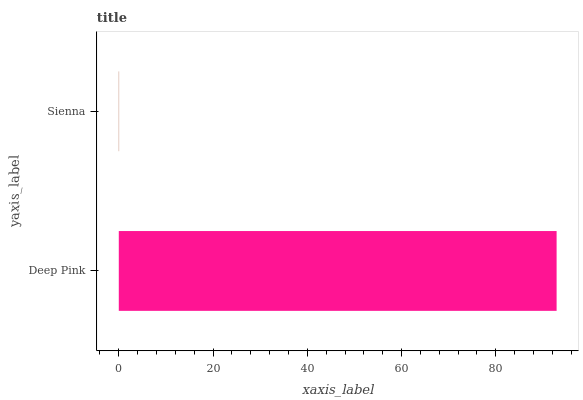Is Sienna the minimum?
Answer yes or no. Yes. Is Deep Pink the maximum?
Answer yes or no. Yes. Is Sienna the maximum?
Answer yes or no. No. Is Deep Pink greater than Sienna?
Answer yes or no. Yes. Is Sienna less than Deep Pink?
Answer yes or no. Yes. Is Sienna greater than Deep Pink?
Answer yes or no. No. Is Deep Pink less than Sienna?
Answer yes or no. No. Is Deep Pink the high median?
Answer yes or no. Yes. Is Sienna the low median?
Answer yes or no. Yes. Is Sienna the high median?
Answer yes or no. No. Is Deep Pink the low median?
Answer yes or no. No. 